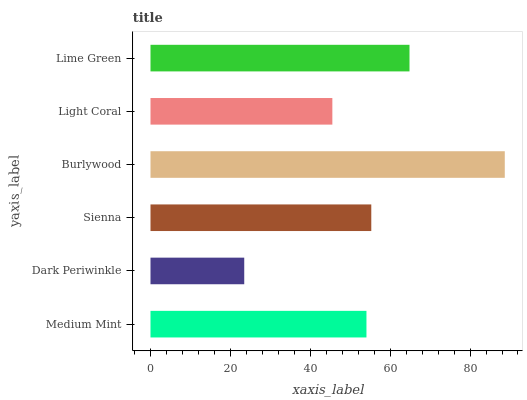Is Dark Periwinkle the minimum?
Answer yes or no. Yes. Is Burlywood the maximum?
Answer yes or no. Yes. Is Sienna the minimum?
Answer yes or no. No. Is Sienna the maximum?
Answer yes or no. No. Is Sienna greater than Dark Periwinkle?
Answer yes or no. Yes. Is Dark Periwinkle less than Sienna?
Answer yes or no. Yes. Is Dark Periwinkle greater than Sienna?
Answer yes or no. No. Is Sienna less than Dark Periwinkle?
Answer yes or no. No. Is Sienna the high median?
Answer yes or no. Yes. Is Medium Mint the low median?
Answer yes or no. Yes. Is Burlywood the high median?
Answer yes or no. No. Is Burlywood the low median?
Answer yes or no. No. 